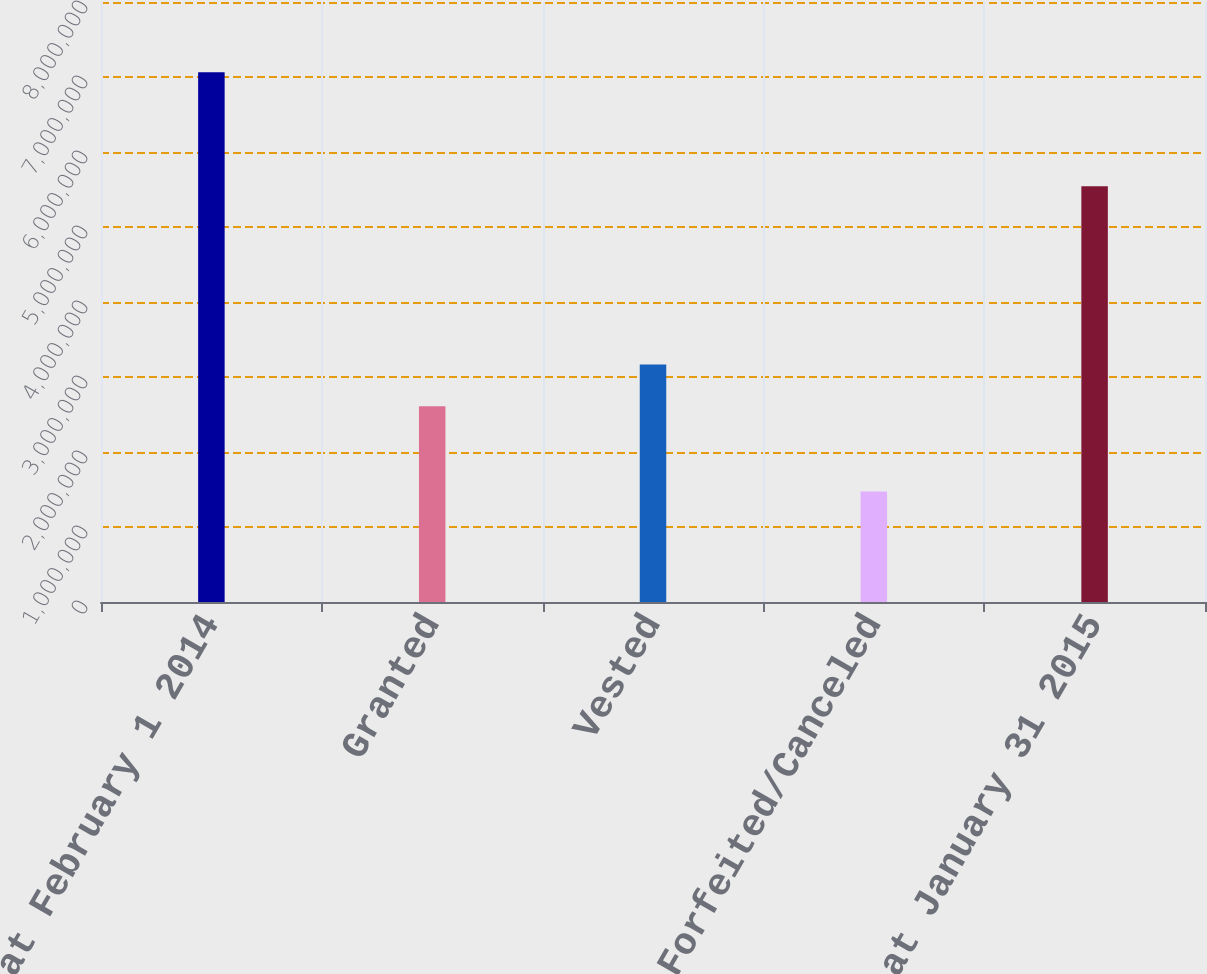<chart> <loc_0><loc_0><loc_500><loc_500><bar_chart><fcel>Outstanding at February 1 2014<fcel>Granted<fcel>Vested<fcel>Forfeited/Canceled<fcel>Outstanding at January 31 2015<nl><fcel>7.065e+06<fcel>2.609e+06<fcel>3.1681e+06<fcel>1.474e+06<fcel>5.543e+06<nl></chart> 